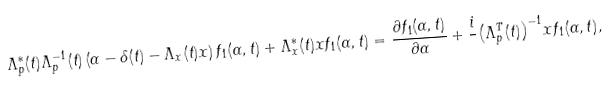<formula> <loc_0><loc_0><loc_500><loc_500>\Lambda ^ { * } _ { p } ( t ) \Lambda ^ { - 1 } _ { p } ( t ) \left ( { \alpha } - { \delta } ( t ) - \Lambda _ { x } ( t ) { x } \right ) f _ { 1 } ( { \alpha } , t ) + \Lambda ^ { * } _ { x } ( t ) { x } f _ { 1 } ( { \alpha } , t ) = \frac { \partial f _ { 1 } ( { \alpha } , t ) } { \partial { \alpha } } + \frac { i } { } { \left ( \Lambda ^ { T } _ { p } ( t ) \right ) } ^ { - 1 } { x } f _ { 1 } ( { \alpha } , t ) ,</formula> 